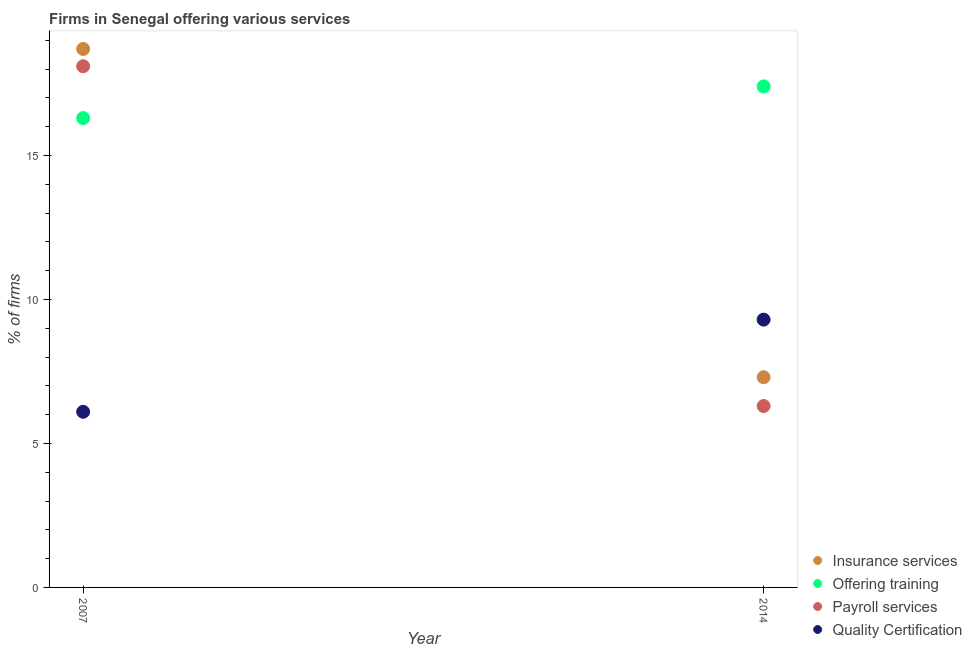Is the number of dotlines equal to the number of legend labels?
Your answer should be very brief. Yes. Across all years, what is the maximum percentage of firms offering insurance services?
Offer a terse response. 18.7. In which year was the percentage of firms offering training maximum?
Offer a terse response. 2014. In which year was the percentage of firms offering payroll services minimum?
Your answer should be compact. 2014. What is the total percentage of firms offering training in the graph?
Keep it short and to the point. 33.7. What is the difference between the percentage of firms offering quality certification in 2007 and that in 2014?
Your answer should be very brief. -3.2. What is the difference between the percentage of firms offering payroll services in 2007 and the percentage of firms offering quality certification in 2014?
Ensure brevity in your answer.  8.8. What is the average percentage of firms offering quality certification per year?
Ensure brevity in your answer.  7.7. In the year 2014, what is the difference between the percentage of firms offering insurance services and percentage of firms offering payroll services?
Your answer should be compact. 1. What is the ratio of the percentage of firms offering payroll services in 2007 to that in 2014?
Your answer should be very brief. 2.87. Is the percentage of firms offering insurance services in 2007 less than that in 2014?
Make the answer very short. No. In how many years, is the percentage of firms offering quality certification greater than the average percentage of firms offering quality certification taken over all years?
Make the answer very short. 1. Is it the case that in every year, the sum of the percentage of firms offering insurance services and percentage of firms offering quality certification is greater than the sum of percentage of firms offering payroll services and percentage of firms offering training?
Provide a succinct answer. No. Is the percentage of firms offering training strictly greater than the percentage of firms offering insurance services over the years?
Offer a terse response. No. What is the difference between two consecutive major ticks on the Y-axis?
Keep it short and to the point. 5. Does the graph contain any zero values?
Keep it short and to the point. No. Does the graph contain grids?
Offer a terse response. No. How are the legend labels stacked?
Ensure brevity in your answer.  Vertical. What is the title of the graph?
Offer a terse response. Firms in Senegal offering various services . What is the label or title of the X-axis?
Your answer should be very brief. Year. What is the label or title of the Y-axis?
Ensure brevity in your answer.  % of firms. What is the % of firms of Insurance services in 2007?
Your answer should be very brief. 18.7. What is the % of firms in Offering training in 2007?
Offer a very short reply. 16.3. What is the % of firms in Insurance services in 2014?
Offer a terse response. 7.3. What is the % of firms of Offering training in 2014?
Your answer should be very brief. 17.4. What is the % of firms in Payroll services in 2014?
Provide a succinct answer. 6.3. Across all years, what is the maximum % of firms of Insurance services?
Provide a succinct answer. 18.7. Across all years, what is the maximum % of firms of Quality Certification?
Give a very brief answer. 9.3. Across all years, what is the minimum % of firms of Payroll services?
Provide a succinct answer. 6.3. Across all years, what is the minimum % of firms in Quality Certification?
Your answer should be very brief. 6.1. What is the total % of firms in Offering training in the graph?
Provide a short and direct response. 33.7. What is the total % of firms in Payroll services in the graph?
Keep it short and to the point. 24.4. What is the difference between the % of firms of Payroll services in 2007 and that in 2014?
Offer a very short reply. 11.8. What is the difference between the % of firms of Insurance services in 2007 and the % of firms of Payroll services in 2014?
Offer a very short reply. 12.4. What is the difference between the % of firms in Insurance services in 2007 and the % of firms in Quality Certification in 2014?
Provide a succinct answer. 9.4. What is the difference between the % of firms in Payroll services in 2007 and the % of firms in Quality Certification in 2014?
Provide a succinct answer. 8.8. What is the average % of firms of Offering training per year?
Ensure brevity in your answer.  16.85. What is the average % of firms of Payroll services per year?
Provide a succinct answer. 12.2. In the year 2007, what is the difference between the % of firms of Insurance services and % of firms of Payroll services?
Your response must be concise. 0.6. In the year 2007, what is the difference between the % of firms of Insurance services and % of firms of Quality Certification?
Keep it short and to the point. 12.6. In the year 2014, what is the difference between the % of firms in Insurance services and % of firms in Offering training?
Give a very brief answer. -10.1. In the year 2014, what is the difference between the % of firms of Insurance services and % of firms of Payroll services?
Offer a terse response. 1. What is the ratio of the % of firms in Insurance services in 2007 to that in 2014?
Keep it short and to the point. 2.56. What is the ratio of the % of firms in Offering training in 2007 to that in 2014?
Offer a very short reply. 0.94. What is the ratio of the % of firms in Payroll services in 2007 to that in 2014?
Make the answer very short. 2.87. What is the ratio of the % of firms of Quality Certification in 2007 to that in 2014?
Your answer should be very brief. 0.66. What is the difference between the highest and the second highest % of firms in Payroll services?
Your answer should be very brief. 11.8. What is the difference between the highest and the second highest % of firms in Quality Certification?
Provide a short and direct response. 3.2. What is the difference between the highest and the lowest % of firms in Insurance services?
Your response must be concise. 11.4. What is the difference between the highest and the lowest % of firms of Offering training?
Provide a short and direct response. 1.1. What is the difference between the highest and the lowest % of firms of Payroll services?
Ensure brevity in your answer.  11.8. 